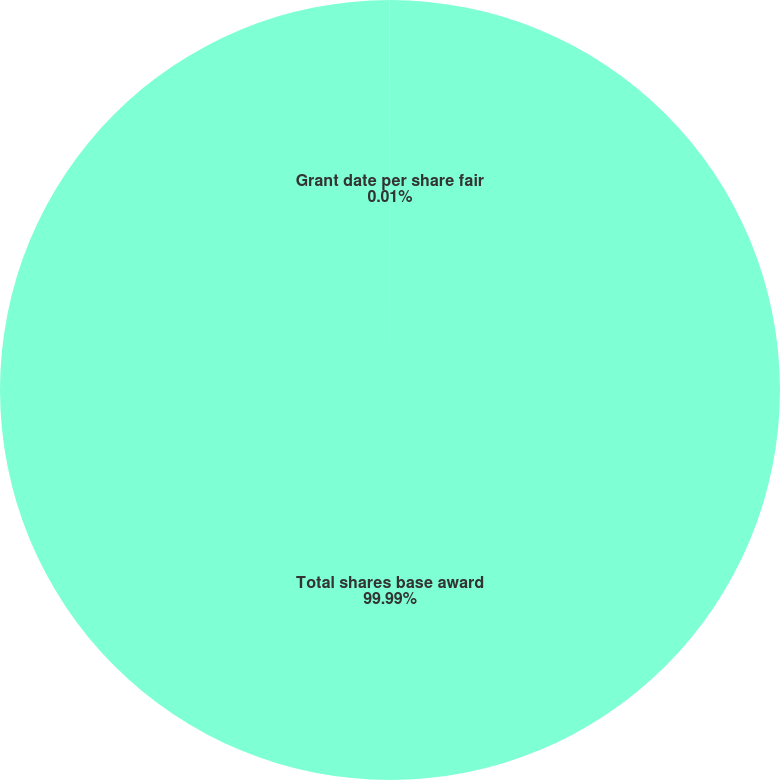<chart> <loc_0><loc_0><loc_500><loc_500><pie_chart><fcel>Total shares base award<fcel>Grant date per share fair<nl><fcel>99.99%<fcel>0.01%<nl></chart> 